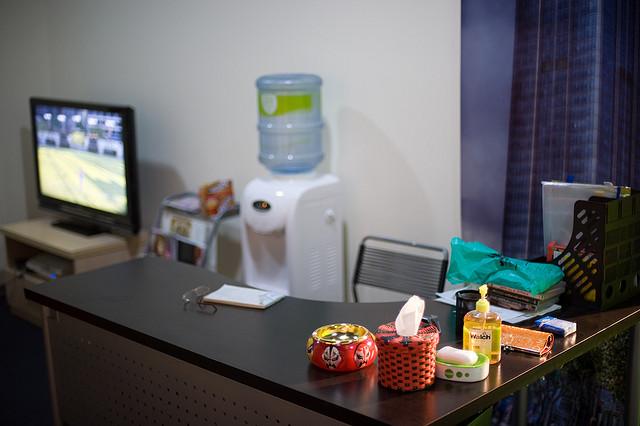What is on the TV?
Write a very short answer. Sports. What item in the picture can be worn?
Be succinct. Glasses. Is there any tissues in the picture?
Write a very short answer. Yes. What type of drink is that?
Concise answer only. Water. Where are the glasses?
Write a very short answer. Desk. Where is the water jug?
Keep it brief. Against wall. 